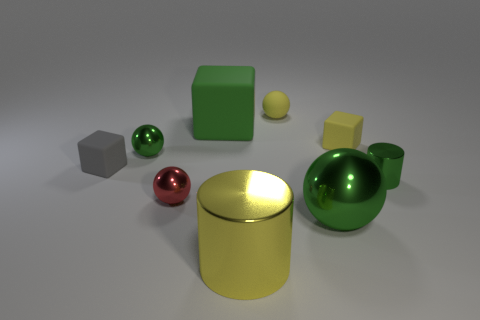Subtract all tiny spheres. How many spheres are left? 1 Subtract all cyan balls. Subtract all green blocks. How many balls are left? 4 Add 1 red things. How many objects exist? 10 Subtract all cylinders. How many objects are left? 7 Subtract 0 blue cylinders. How many objects are left? 9 Subtract all yellow rubber things. Subtract all large balls. How many objects are left? 6 Add 9 large spheres. How many large spheres are left? 10 Add 1 small cyan rubber balls. How many small cyan rubber balls exist? 1 